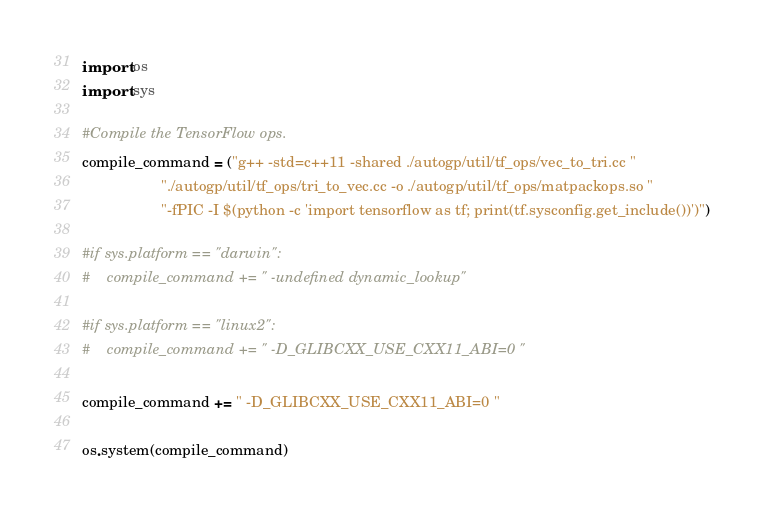<code> <loc_0><loc_0><loc_500><loc_500><_Python_>import os
import sys

#Compile the TensorFlow ops.
compile_command = ("g++ -std=c++11 -shared ./autogp/util/tf_ops/vec_to_tri.cc "
                   "./autogp/util/tf_ops/tri_to_vec.cc -o ./autogp/util/tf_ops/matpackops.so "
                   "-fPIC -I $(python -c 'import tensorflow as tf; print(tf.sysconfig.get_include())')")

#if sys.platform == "darwin":
#    compile_command += " -undefined dynamic_lookup"

#if sys.platform == "linux2":
#    compile_command += " -D_GLIBCXX_USE_CXX11_ABI=0 "

compile_command += " -D_GLIBCXX_USE_CXX11_ABI=0 "

os.system(compile_command)
</code> 